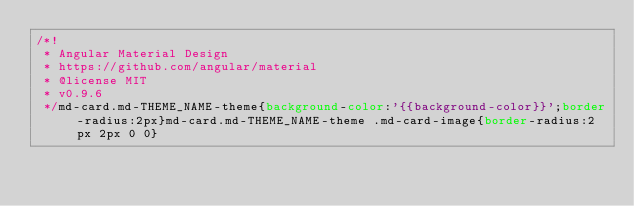<code> <loc_0><loc_0><loc_500><loc_500><_CSS_>/*!
 * Angular Material Design
 * https://github.com/angular/material
 * @license MIT
 * v0.9.6
 */md-card.md-THEME_NAME-theme{background-color:'{{background-color}}';border-radius:2px}md-card.md-THEME_NAME-theme .md-card-image{border-radius:2px 2px 0 0}</code> 